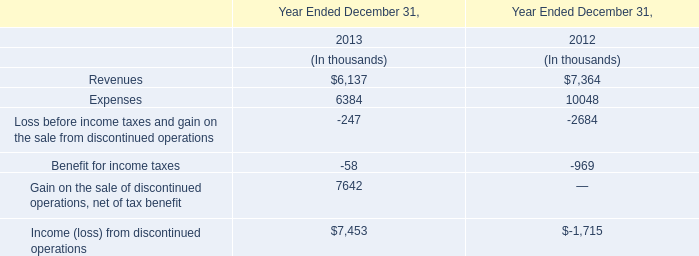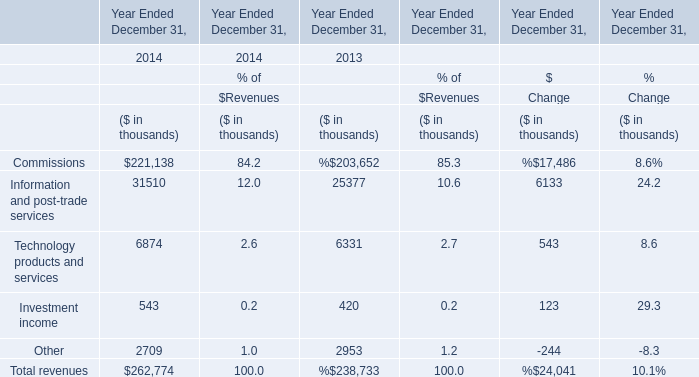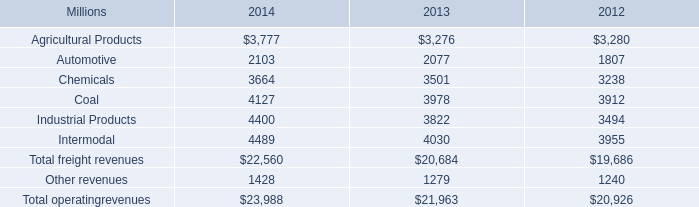In which Year Ended December 31 is Investment income smaller than 510 thousand? 
Answer: 2013. 